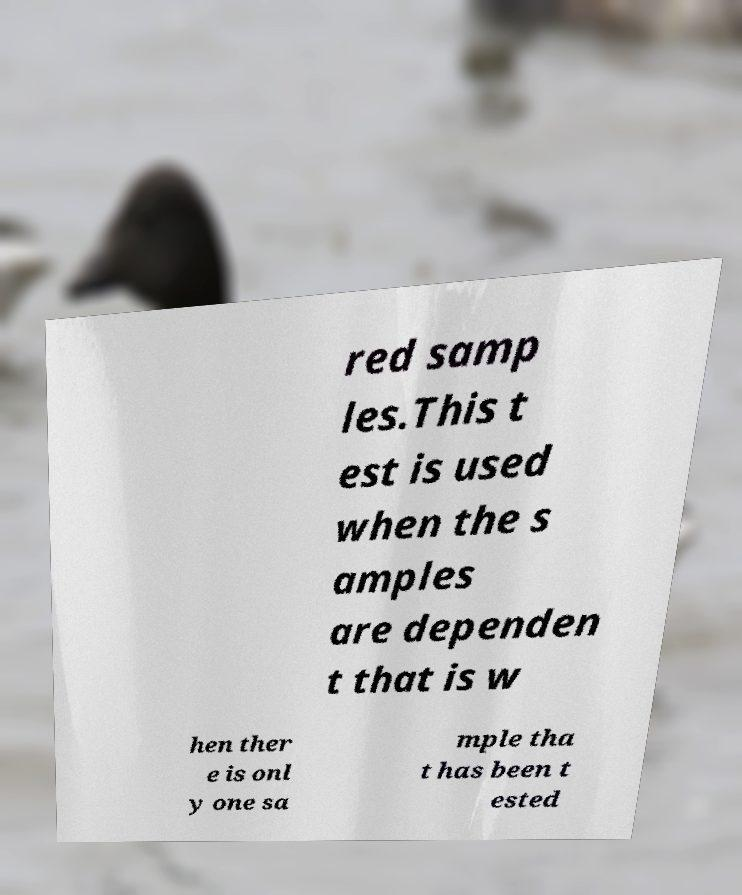Could you assist in decoding the text presented in this image and type it out clearly? red samp les.This t est is used when the s amples are dependen t that is w hen ther e is onl y one sa mple tha t has been t ested 